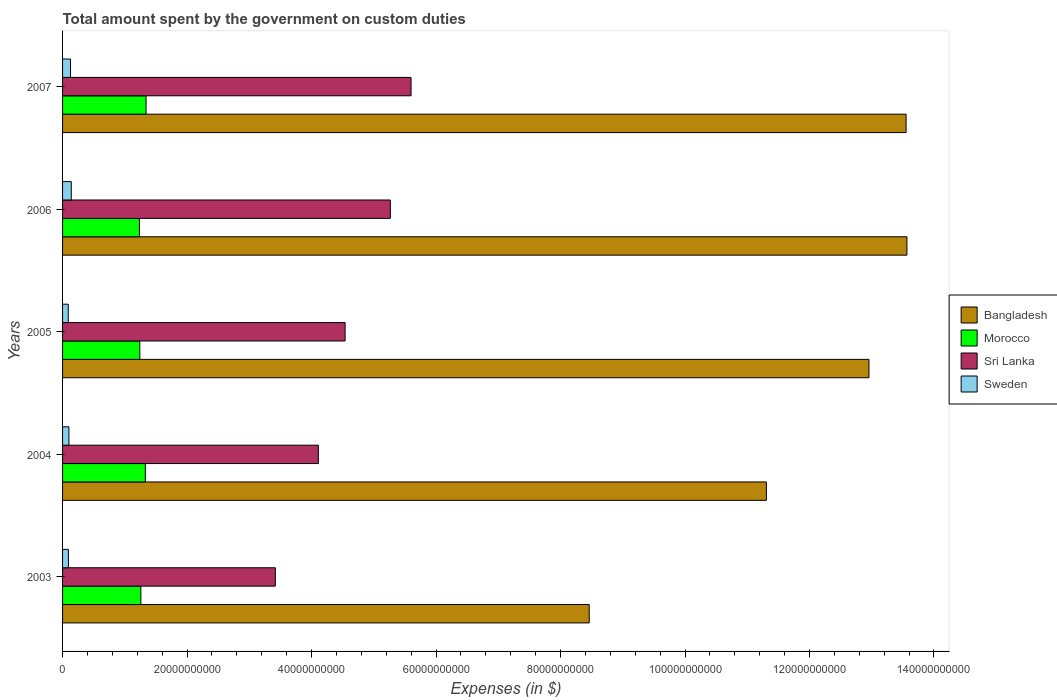How many different coloured bars are there?
Offer a very short reply. 4. How many bars are there on the 1st tick from the top?
Your response must be concise. 4. In how many cases, is the number of bars for a given year not equal to the number of legend labels?
Offer a very short reply. 0. What is the amount spent on custom duties by the government in Sri Lanka in 2006?
Ensure brevity in your answer.  5.27e+1. Across all years, what is the maximum amount spent on custom duties by the government in Morocco?
Provide a short and direct response. 1.34e+1. Across all years, what is the minimum amount spent on custom duties by the government in Sri Lanka?
Make the answer very short. 3.42e+1. What is the total amount spent on custom duties by the government in Sri Lanka in the graph?
Make the answer very short. 2.29e+11. What is the difference between the amount spent on custom duties by the government in Sri Lanka in 2006 and that in 2007?
Give a very brief answer. -3.33e+09. What is the difference between the amount spent on custom duties by the government in Sweden in 2004 and the amount spent on custom duties by the government in Sri Lanka in 2003?
Give a very brief answer. -3.32e+1. What is the average amount spent on custom duties by the government in Sri Lanka per year?
Offer a terse response. 4.59e+1. In the year 2004, what is the difference between the amount spent on custom duties by the government in Morocco and amount spent on custom duties by the government in Bangladesh?
Provide a succinct answer. -9.98e+1. What is the ratio of the amount spent on custom duties by the government in Sweden in 2003 to that in 2005?
Keep it short and to the point. 1.03. Is the difference between the amount spent on custom duties by the government in Morocco in 2003 and 2006 greater than the difference between the amount spent on custom duties by the government in Bangladesh in 2003 and 2006?
Make the answer very short. Yes. What is the difference between the highest and the second highest amount spent on custom duties by the government in Morocco?
Provide a short and direct response. 1.22e+08. What is the difference between the highest and the lowest amount spent on custom duties by the government in Morocco?
Your answer should be compact. 1.07e+09. Is it the case that in every year, the sum of the amount spent on custom duties by the government in Sweden and amount spent on custom duties by the government in Morocco is greater than the sum of amount spent on custom duties by the government in Bangladesh and amount spent on custom duties by the government in Sri Lanka?
Provide a succinct answer. No. What does the 2nd bar from the top in 2007 represents?
Offer a terse response. Sri Lanka. What does the 3rd bar from the bottom in 2004 represents?
Ensure brevity in your answer.  Sri Lanka. Is it the case that in every year, the sum of the amount spent on custom duties by the government in Sweden and amount spent on custom duties by the government in Sri Lanka is greater than the amount spent on custom duties by the government in Morocco?
Your answer should be compact. Yes. Are the values on the major ticks of X-axis written in scientific E-notation?
Give a very brief answer. No. Does the graph contain grids?
Keep it short and to the point. No. Where does the legend appear in the graph?
Make the answer very short. Center right. How many legend labels are there?
Provide a short and direct response. 4. How are the legend labels stacked?
Keep it short and to the point. Vertical. What is the title of the graph?
Your response must be concise. Total amount spent by the government on custom duties. Does "Maldives" appear as one of the legend labels in the graph?
Give a very brief answer. No. What is the label or title of the X-axis?
Offer a very short reply. Expenses (in $). What is the Expenses (in $) of Bangladesh in 2003?
Your answer should be very brief. 8.46e+1. What is the Expenses (in $) in Morocco in 2003?
Your answer should be compact. 1.26e+1. What is the Expenses (in $) in Sri Lanka in 2003?
Provide a succinct answer. 3.42e+1. What is the Expenses (in $) of Sweden in 2003?
Provide a succinct answer. 9.39e+08. What is the Expenses (in $) of Bangladesh in 2004?
Your answer should be very brief. 1.13e+11. What is the Expenses (in $) in Morocco in 2004?
Make the answer very short. 1.33e+1. What is the Expenses (in $) in Sri Lanka in 2004?
Offer a terse response. 4.11e+1. What is the Expenses (in $) of Sweden in 2004?
Keep it short and to the point. 1.02e+09. What is the Expenses (in $) of Bangladesh in 2005?
Provide a succinct answer. 1.30e+11. What is the Expenses (in $) in Morocco in 2005?
Give a very brief answer. 1.24e+1. What is the Expenses (in $) in Sri Lanka in 2005?
Give a very brief answer. 4.54e+1. What is the Expenses (in $) in Sweden in 2005?
Provide a succinct answer. 9.12e+08. What is the Expenses (in $) of Bangladesh in 2006?
Provide a succinct answer. 1.36e+11. What is the Expenses (in $) in Morocco in 2006?
Offer a very short reply. 1.23e+1. What is the Expenses (in $) of Sri Lanka in 2006?
Provide a succinct answer. 5.27e+1. What is the Expenses (in $) in Sweden in 2006?
Make the answer very short. 1.40e+09. What is the Expenses (in $) in Bangladesh in 2007?
Your response must be concise. 1.36e+11. What is the Expenses (in $) of Morocco in 2007?
Ensure brevity in your answer.  1.34e+1. What is the Expenses (in $) of Sri Lanka in 2007?
Make the answer very short. 5.60e+1. What is the Expenses (in $) of Sweden in 2007?
Your answer should be compact. 1.28e+09. Across all years, what is the maximum Expenses (in $) in Bangladesh?
Offer a very short reply. 1.36e+11. Across all years, what is the maximum Expenses (in $) of Morocco?
Your answer should be compact. 1.34e+1. Across all years, what is the maximum Expenses (in $) of Sri Lanka?
Keep it short and to the point. 5.60e+1. Across all years, what is the maximum Expenses (in $) of Sweden?
Offer a very short reply. 1.40e+09. Across all years, what is the minimum Expenses (in $) of Bangladesh?
Keep it short and to the point. 8.46e+1. Across all years, what is the minimum Expenses (in $) in Morocco?
Your answer should be compact. 1.23e+1. Across all years, what is the minimum Expenses (in $) in Sri Lanka?
Make the answer very short. 3.42e+1. Across all years, what is the minimum Expenses (in $) of Sweden?
Your answer should be very brief. 9.12e+08. What is the total Expenses (in $) in Bangladesh in the graph?
Make the answer very short. 5.98e+11. What is the total Expenses (in $) of Morocco in the graph?
Offer a terse response. 6.40e+1. What is the total Expenses (in $) of Sri Lanka in the graph?
Provide a short and direct response. 2.29e+11. What is the total Expenses (in $) of Sweden in the graph?
Provide a short and direct response. 5.55e+09. What is the difference between the Expenses (in $) in Bangladesh in 2003 and that in 2004?
Make the answer very short. -2.85e+1. What is the difference between the Expenses (in $) of Morocco in 2003 and that in 2004?
Make the answer very short. -7.15e+08. What is the difference between the Expenses (in $) in Sri Lanka in 2003 and that in 2004?
Provide a succinct answer. -6.91e+09. What is the difference between the Expenses (in $) of Sweden in 2003 and that in 2004?
Give a very brief answer. -8.30e+07. What is the difference between the Expenses (in $) of Bangladesh in 2003 and that in 2005?
Your answer should be compact. -4.49e+1. What is the difference between the Expenses (in $) in Morocco in 2003 and that in 2005?
Ensure brevity in your answer.  1.69e+08. What is the difference between the Expenses (in $) in Sri Lanka in 2003 and that in 2005?
Make the answer very short. -1.12e+1. What is the difference between the Expenses (in $) of Sweden in 2003 and that in 2005?
Ensure brevity in your answer.  2.70e+07. What is the difference between the Expenses (in $) in Bangladesh in 2003 and that in 2006?
Offer a terse response. -5.10e+1. What is the difference between the Expenses (in $) in Morocco in 2003 and that in 2006?
Keep it short and to the point. 2.34e+08. What is the difference between the Expenses (in $) of Sri Lanka in 2003 and that in 2006?
Make the answer very short. -1.85e+1. What is the difference between the Expenses (in $) in Sweden in 2003 and that in 2006?
Offer a terse response. -4.61e+08. What is the difference between the Expenses (in $) of Bangladesh in 2003 and that in 2007?
Give a very brief answer. -5.09e+1. What is the difference between the Expenses (in $) of Morocco in 2003 and that in 2007?
Ensure brevity in your answer.  -8.37e+08. What is the difference between the Expenses (in $) in Sri Lanka in 2003 and that in 2007?
Give a very brief answer. -2.18e+1. What is the difference between the Expenses (in $) in Sweden in 2003 and that in 2007?
Provide a short and direct response. -3.41e+08. What is the difference between the Expenses (in $) of Bangladesh in 2004 and that in 2005?
Provide a short and direct response. -1.65e+1. What is the difference between the Expenses (in $) in Morocco in 2004 and that in 2005?
Give a very brief answer. 8.84e+08. What is the difference between the Expenses (in $) in Sri Lanka in 2004 and that in 2005?
Make the answer very short. -4.29e+09. What is the difference between the Expenses (in $) of Sweden in 2004 and that in 2005?
Provide a short and direct response. 1.10e+08. What is the difference between the Expenses (in $) in Bangladesh in 2004 and that in 2006?
Offer a terse response. -2.26e+1. What is the difference between the Expenses (in $) of Morocco in 2004 and that in 2006?
Provide a succinct answer. 9.49e+08. What is the difference between the Expenses (in $) in Sri Lanka in 2004 and that in 2006?
Ensure brevity in your answer.  -1.16e+1. What is the difference between the Expenses (in $) in Sweden in 2004 and that in 2006?
Make the answer very short. -3.78e+08. What is the difference between the Expenses (in $) of Bangladesh in 2004 and that in 2007?
Give a very brief answer. -2.24e+1. What is the difference between the Expenses (in $) in Morocco in 2004 and that in 2007?
Offer a terse response. -1.22e+08. What is the difference between the Expenses (in $) of Sri Lanka in 2004 and that in 2007?
Your answer should be compact. -1.49e+1. What is the difference between the Expenses (in $) of Sweden in 2004 and that in 2007?
Make the answer very short. -2.58e+08. What is the difference between the Expenses (in $) in Bangladesh in 2005 and that in 2006?
Provide a short and direct response. -6.10e+09. What is the difference between the Expenses (in $) in Morocco in 2005 and that in 2006?
Provide a short and direct response. 6.50e+07. What is the difference between the Expenses (in $) of Sri Lanka in 2005 and that in 2006?
Give a very brief answer. -7.27e+09. What is the difference between the Expenses (in $) of Sweden in 2005 and that in 2006?
Offer a terse response. -4.88e+08. What is the difference between the Expenses (in $) in Bangladesh in 2005 and that in 2007?
Provide a short and direct response. -5.96e+09. What is the difference between the Expenses (in $) of Morocco in 2005 and that in 2007?
Your answer should be compact. -1.01e+09. What is the difference between the Expenses (in $) of Sri Lanka in 2005 and that in 2007?
Give a very brief answer. -1.06e+1. What is the difference between the Expenses (in $) of Sweden in 2005 and that in 2007?
Offer a terse response. -3.68e+08. What is the difference between the Expenses (in $) of Bangladesh in 2006 and that in 2007?
Offer a very short reply. 1.33e+08. What is the difference between the Expenses (in $) of Morocco in 2006 and that in 2007?
Keep it short and to the point. -1.07e+09. What is the difference between the Expenses (in $) in Sri Lanka in 2006 and that in 2007?
Offer a very short reply. -3.33e+09. What is the difference between the Expenses (in $) of Sweden in 2006 and that in 2007?
Make the answer very short. 1.20e+08. What is the difference between the Expenses (in $) of Bangladesh in 2003 and the Expenses (in $) of Morocco in 2004?
Make the answer very short. 7.13e+1. What is the difference between the Expenses (in $) in Bangladesh in 2003 and the Expenses (in $) in Sri Lanka in 2004?
Offer a very short reply. 4.35e+1. What is the difference between the Expenses (in $) in Bangladesh in 2003 and the Expenses (in $) in Sweden in 2004?
Ensure brevity in your answer.  8.36e+1. What is the difference between the Expenses (in $) of Morocco in 2003 and the Expenses (in $) of Sri Lanka in 2004?
Offer a terse response. -2.85e+1. What is the difference between the Expenses (in $) of Morocco in 2003 and the Expenses (in $) of Sweden in 2004?
Keep it short and to the point. 1.16e+1. What is the difference between the Expenses (in $) in Sri Lanka in 2003 and the Expenses (in $) in Sweden in 2004?
Make the answer very short. 3.32e+1. What is the difference between the Expenses (in $) in Bangladesh in 2003 and the Expenses (in $) in Morocco in 2005?
Your response must be concise. 7.22e+1. What is the difference between the Expenses (in $) of Bangladesh in 2003 and the Expenses (in $) of Sri Lanka in 2005?
Offer a very short reply. 3.92e+1. What is the difference between the Expenses (in $) of Bangladesh in 2003 and the Expenses (in $) of Sweden in 2005?
Keep it short and to the point. 8.37e+1. What is the difference between the Expenses (in $) of Morocco in 2003 and the Expenses (in $) of Sri Lanka in 2005?
Your response must be concise. -3.28e+1. What is the difference between the Expenses (in $) in Morocco in 2003 and the Expenses (in $) in Sweden in 2005?
Make the answer very short. 1.17e+1. What is the difference between the Expenses (in $) in Sri Lanka in 2003 and the Expenses (in $) in Sweden in 2005?
Make the answer very short. 3.33e+1. What is the difference between the Expenses (in $) of Bangladesh in 2003 and the Expenses (in $) of Morocco in 2006?
Offer a very short reply. 7.23e+1. What is the difference between the Expenses (in $) in Bangladesh in 2003 and the Expenses (in $) in Sri Lanka in 2006?
Provide a succinct answer. 3.19e+1. What is the difference between the Expenses (in $) in Bangladesh in 2003 and the Expenses (in $) in Sweden in 2006?
Make the answer very short. 8.32e+1. What is the difference between the Expenses (in $) in Morocco in 2003 and the Expenses (in $) in Sri Lanka in 2006?
Your answer should be compact. -4.01e+1. What is the difference between the Expenses (in $) in Morocco in 2003 and the Expenses (in $) in Sweden in 2006?
Your answer should be compact. 1.12e+1. What is the difference between the Expenses (in $) in Sri Lanka in 2003 and the Expenses (in $) in Sweden in 2006?
Your answer should be very brief. 3.28e+1. What is the difference between the Expenses (in $) of Bangladesh in 2003 and the Expenses (in $) of Morocco in 2007?
Make the answer very short. 7.12e+1. What is the difference between the Expenses (in $) of Bangladesh in 2003 and the Expenses (in $) of Sri Lanka in 2007?
Your answer should be compact. 2.86e+1. What is the difference between the Expenses (in $) in Bangladesh in 2003 and the Expenses (in $) in Sweden in 2007?
Offer a very short reply. 8.33e+1. What is the difference between the Expenses (in $) in Morocco in 2003 and the Expenses (in $) in Sri Lanka in 2007?
Provide a succinct answer. -4.34e+1. What is the difference between the Expenses (in $) in Morocco in 2003 and the Expenses (in $) in Sweden in 2007?
Offer a terse response. 1.13e+1. What is the difference between the Expenses (in $) of Sri Lanka in 2003 and the Expenses (in $) of Sweden in 2007?
Your answer should be very brief. 3.29e+1. What is the difference between the Expenses (in $) in Bangladesh in 2004 and the Expenses (in $) in Morocco in 2005?
Keep it short and to the point. 1.01e+11. What is the difference between the Expenses (in $) of Bangladesh in 2004 and the Expenses (in $) of Sri Lanka in 2005?
Give a very brief answer. 6.77e+1. What is the difference between the Expenses (in $) in Bangladesh in 2004 and the Expenses (in $) in Sweden in 2005?
Offer a very short reply. 1.12e+11. What is the difference between the Expenses (in $) in Morocco in 2004 and the Expenses (in $) in Sri Lanka in 2005?
Your answer should be very brief. -3.21e+1. What is the difference between the Expenses (in $) in Morocco in 2004 and the Expenses (in $) in Sweden in 2005?
Your answer should be compact. 1.24e+1. What is the difference between the Expenses (in $) of Sri Lanka in 2004 and the Expenses (in $) of Sweden in 2005?
Ensure brevity in your answer.  4.02e+1. What is the difference between the Expenses (in $) of Bangladesh in 2004 and the Expenses (in $) of Morocco in 2006?
Your answer should be compact. 1.01e+11. What is the difference between the Expenses (in $) in Bangladesh in 2004 and the Expenses (in $) in Sri Lanka in 2006?
Make the answer very short. 6.04e+1. What is the difference between the Expenses (in $) in Bangladesh in 2004 and the Expenses (in $) in Sweden in 2006?
Give a very brief answer. 1.12e+11. What is the difference between the Expenses (in $) in Morocco in 2004 and the Expenses (in $) in Sri Lanka in 2006?
Keep it short and to the point. -3.94e+1. What is the difference between the Expenses (in $) in Morocco in 2004 and the Expenses (in $) in Sweden in 2006?
Make the answer very short. 1.19e+1. What is the difference between the Expenses (in $) in Sri Lanka in 2004 and the Expenses (in $) in Sweden in 2006?
Your answer should be very brief. 3.97e+1. What is the difference between the Expenses (in $) of Bangladesh in 2004 and the Expenses (in $) of Morocco in 2007?
Your answer should be very brief. 9.97e+1. What is the difference between the Expenses (in $) of Bangladesh in 2004 and the Expenses (in $) of Sri Lanka in 2007?
Your answer should be compact. 5.71e+1. What is the difference between the Expenses (in $) in Bangladesh in 2004 and the Expenses (in $) in Sweden in 2007?
Make the answer very short. 1.12e+11. What is the difference between the Expenses (in $) in Morocco in 2004 and the Expenses (in $) in Sri Lanka in 2007?
Keep it short and to the point. -4.27e+1. What is the difference between the Expenses (in $) in Morocco in 2004 and the Expenses (in $) in Sweden in 2007?
Your response must be concise. 1.20e+1. What is the difference between the Expenses (in $) in Sri Lanka in 2004 and the Expenses (in $) in Sweden in 2007?
Provide a succinct answer. 3.98e+1. What is the difference between the Expenses (in $) in Bangladesh in 2005 and the Expenses (in $) in Morocco in 2006?
Make the answer very short. 1.17e+11. What is the difference between the Expenses (in $) of Bangladesh in 2005 and the Expenses (in $) of Sri Lanka in 2006?
Make the answer very short. 7.69e+1. What is the difference between the Expenses (in $) in Bangladesh in 2005 and the Expenses (in $) in Sweden in 2006?
Provide a short and direct response. 1.28e+11. What is the difference between the Expenses (in $) in Morocco in 2005 and the Expenses (in $) in Sri Lanka in 2006?
Offer a very short reply. -4.03e+1. What is the difference between the Expenses (in $) in Morocco in 2005 and the Expenses (in $) in Sweden in 2006?
Make the answer very short. 1.10e+1. What is the difference between the Expenses (in $) of Sri Lanka in 2005 and the Expenses (in $) of Sweden in 2006?
Provide a succinct answer. 4.40e+1. What is the difference between the Expenses (in $) of Bangladesh in 2005 and the Expenses (in $) of Morocco in 2007?
Ensure brevity in your answer.  1.16e+11. What is the difference between the Expenses (in $) of Bangladesh in 2005 and the Expenses (in $) of Sri Lanka in 2007?
Keep it short and to the point. 7.36e+1. What is the difference between the Expenses (in $) in Bangladesh in 2005 and the Expenses (in $) in Sweden in 2007?
Provide a short and direct response. 1.28e+11. What is the difference between the Expenses (in $) of Morocco in 2005 and the Expenses (in $) of Sri Lanka in 2007?
Your answer should be very brief. -4.36e+1. What is the difference between the Expenses (in $) in Morocco in 2005 and the Expenses (in $) in Sweden in 2007?
Ensure brevity in your answer.  1.11e+1. What is the difference between the Expenses (in $) of Sri Lanka in 2005 and the Expenses (in $) of Sweden in 2007?
Ensure brevity in your answer.  4.41e+1. What is the difference between the Expenses (in $) in Bangladesh in 2006 and the Expenses (in $) in Morocco in 2007?
Provide a short and direct response. 1.22e+11. What is the difference between the Expenses (in $) of Bangladesh in 2006 and the Expenses (in $) of Sri Lanka in 2007?
Ensure brevity in your answer.  7.97e+1. What is the difference between the Expenses (in $) in Bangladesh in 2006 and the Expenses (in $) in Sweden in 2007?
Keep it short and to the point. 1.34e+11. What is the difference between the Expenses (in $) of Morocco in 2006 and the Expenses (in $) of Sri Lanka in 2007?
Provide a short and direct response. -4.36e+1. What is the difference between the Expenses (in $) in Morocco in 2006 and the Expenses (in $) in Sweden in 2007?
Keep it short and to the point. 1.11e+1. What is the difference between the Expenses (in $) in Sri Lanka in 2006 and the Expenses (in $) in Sweden in 2007?
Ensure brevity in your answer.  5.14e+1. What is the average Expenses (in $) of Bangladesh per year?
Offer a terse response. 1.20e+11. What is the average Expenses (in $) of Morocco per year?
Provide a short and direct response. 1.28e+1. What is the average Expenses (in $) of Sri Lanka per year?
Your answer should be compact. 4.59e+1. What is the average Expenses (in $) of Sweden per year?
Provide a succinct answer. 1.11e+09. In the year 2003, what is the difference between the Expenses (in $) of Bangladesh and Expenses (in $) of Morocco?
Ensure brevity in your answer.  7.20e+1. In the year 2003, what is the difference between the Expenses (in $) of Bangladesh and Expenses (in $) of Sri Lanka?
Keep it short and to the point. 5.04e+1. In the year 2003, what is the difference between the Expenses (in $) in Bangladesh and Expenses (in $) in Sweden?
Give a very brief answer. 8.37e+1. In the year 2003, what is the difference between the Expenses (in $) in Morocco and Expenses (in $) in Sri Lanka?
Keep it short and to the point. -2.16e+1. In the year 2003, what is the difference between the Expenses (in $) of Morocco and Expenses (in $) of Sweden?
Keep it short and to the point. 1.16e+1. In the year 2003, what is the difference between the Expenses (in $) of Sri Lanka and Expenses (in $) of Sweden?
Offer a very short reply. 3.32e+1. In the year 2004, what is the difference between the Expenses (in $) of Bangladesh and Expenses (in $) of Morocco?
Make the answer very short. 9.98e+1. In the year 2004, what is the difference between the Expenses (in $) of Bangladesh and Expenses (in $) of Sri Lanka?
Your response must be concise. 7.20e+1. In the year 2004, what is the difference between the Expenses (in $) of Bangladesh and Expenses (in $) of Sweden?
Make the answer very short. 1.12e+11. In the year 2004, what is the difference between the Expenses (in $) in Morocco and Expenses (in $) in Sri Lanka?
Give a very brief answer. -2.78e+1. In the year 2004, what is the difference between the Expenses (in $) in Morocco and Expenses (in $) in Sweden?
Give a very brief answer. 1.23e+1. In the year 2004, what is the difference between the Expenses (in $) in Sri Lanka and Expenses (in $) in Sweden?
Provide a succinct answer. 4.01e+1. In the year 2005, what is the difference between the Expenses (in $) in Bangladesh and Expenses (in $) in Morocco?
Offer a very short reply. 1.17e+11. In the year 2005, what is the difference between the Expenses (in $) in Bangladesh and Expenses (in $) in Sri Lanka?
Provide a short and direct response. 8.42e+1. In the year 2005, what is the difference between the Expenses (in $) in Bangladesh and Expenses (in $) in Sweden?
Make the answer very short. 1.29e+11. In the year 2005, what is the difference between the Expenses (in $) of Morocco and Expenses (in $) of Sri Lanka?
Your response must be concise. -3.30e+1. In the year 2005, what is the difference between the Expenses (in $) in Morocco and Expenses (in $) in Sweden?
Provide a short and direct response. 1.15e+1. In the year 2005, what is the difference between the Expenses (in $) of Sri Lanka and Expenses (in $) of Sweden?
Ensure brevity in your answer.  4.45e+1. In the year 2006, what is the difference between the Expenses (in $) of Bangladesh and Expenses (in $) of Morocco?
Offer a very short reply. 1.23e+11. In the year 2006, what is the difference between the Expenses (in $) in Bangladesh and Expenses (in $) in Sri Lanka?
Provide a succinct answer. 8.30e+1. In the year 2006, what is the difference between the Expenses (in $) of Bangladesh and Expenses (in $) of Sweden?
Your answer should be compact. 1.34e+11. In the year 2006, what is the difference between the Expenses (in $) in Morocco and Expenses (in $) in Sri Lanka?
Ensure brevity in your answer.  -4.03e+1. In the year 2006, what is the difference between the Expenses (in $) of Morocco and Expenses (in $) of Sweden?
Offer a very short reply. 1.09e+1. In the year 2006, what is the difference between the Expenses (in $) of Sri Lanka and Expenses (in $) of Sweden?
Ensure brevity in your answer.  5.13e+1. In the year 2007, what is the difference between the Expenses (in $) of Bangladesh and Expenses (in $) of Morocco?
Your response must be concise. 1.22e+11. In the year 2007, what is the difference between the Expenses (in $) in Bangladesh and Expenses (in $) in Sri Lanka?
Keep it short and to the point. 7.95e+1. In the year 2007, what is the difference between the Expenses (in $) in Bangladesh and Expenses (in $) in Sweden?
Make the answer very short. 1.34e+11. In the year 2007, what is the difference between the Expenses (in $) of Morocco and Expenses (in $) of Sri Lanka?
Provide a succinct answer. -4.26e+1. In the year 2007, what is the difference between the Expenses (in $) in Morocco and Expenses (in $) in Sweden?
Make the answer very short. 1.21e+1. In the year 2007, what is the difference between the Expenses (in $) of Sri Lanka and Expenses (in $) of Sweden?
Provide a short and direct response. 5.47e+1. What is the ratio of the Expenses (in $) in Bangladesh in 2003 to that in 2004?
Your answer should be compact. 0.75. What is the ratio of the Expenses (in $) of Morocco in 2003 to that in 2004?
Provide a succinct answer. 0.95. What is the ratio of the Expenses (in $) in Sri Lanka in 2003 to that in 2004?
Provide a short and direct response. 0.83. What is the ratio of the Expenses (in $) in Sweden in 2003 to that in 2004?
Offer a terse response. 0.92. What is the ratio of the Expenses (in $) in Bangladesh in 2003 to that in 2005?
Provide a short and direct response. 0.65. What is the ratio of the Expenses (in $) of Morocco in 2003 to that in 2005?
Offer a terse response. 1.01. What is the ratio of the Expenses (in $) in Sri Lanka in 2003 to that in 2005?
Keep it short and to the point. 0.75. What is the ratio of the Expenses (in $) in Sweden in 2003 to that in 2005?
Make the answer very short. 1.03. What is the ratio of the Expenses (in $) of Bangladesh in 2003 to that in 2006?
Provide a succinct answer. 0.62. What is the ratio of the Expenses (in $) of Morocco in 2003 to that in 2006?
Provide a succinct answer. 1.02. What is the ratio of the Expenses (in $) in Sri Lanka in 2003 to that in 2006?
Provide a succinct answer. 0.65. What is the ratio of the Expenses (in $) in Sweden in 2003 to that in 2006?
Offer a terse response. 0.67. What is the ratio of the Expenses (in $) in Bangladesh in 2003 to that in 2007?
Provide a short and direct response. 0.62. What is the ratio of the Expenses (in $) of Morocco in 2003 to that in 2007?
Offer a very short reply. 0.94. What is the ratio of the Expenses (in $) of Sri Lanka in 2003 to that in 2007?
Offer a very short reply. 0.61. What is the ratio of the Expenses (in $) in Sweden in 2003 to that in 2007?
Your response must be concise. 0.73. What is the ratio of the Expenses (in $) of Bangladesh in 2004 to that in 2005?
Offer a very short reply. 0.87. What is the ratio of the Expenses (in $) of Morocco in 2004 to that in 2005?
Keep it short and to the point. 1.07. What is the ratio of the Expenses (in $) in Sri Lanka in 2004 to that in 2005?
Provide a short and direct response. 0.91. What is the ratio of the Expenses (in $) of Sweden in 2004 to that in 2005?
Your answer should be compact. 1.12. What is the ratio of the Expenses (in $) in Bangladesh in 2004 to that in 2006?
Keep it short and to the point. 0.83. What is the ratio of the Expenses (in $) in Morocco in 2004 to that in 2006?
Provide a short and direct response. 1.08. What is the ratio of the Expenses (in $) of Sri Lanka in 2004 to that in 2006?
Offer a terse response. 0.78. What is the ratio of the Expenses (in $) in Sweden in 2004 to that in 2006?
Your answer should be very brief. 0.73. What is the ratio of the Expenses (in $) of Bangladesh in 2004 to that in 2007?
Your response must be concise. 0.83. What is the ratio of the Expenses (in $) of Morocco in 2004 to that in 2007?
Keep it short and to the point. 0.99. What is the ratio of the Expenses (in $) of Sri Lanka in 2004 to that in 2007?
Offer a very short reply. 0.73. What is the ratio of the Expenses (in $) in Sweden in 2004 to that in 2007?
Your answer should be very brief. 0.8. What is the ratio of the Expenses (in $) of Bangladesh in 2005 to that in 2006?
Your answer should be very brief. 0.95. What is the ratio of the Expenses (in $) of Morocco in 2005 to that in 2006?
Make the answer very short. 1.01. What is the ratio of the Expenses (in $) in Sri Lanka in 2005 to that in 2006?
Provide a short and direct response. 0.86. What is the ratio of the Expenses (in $) of Sweden in 2005 to that in 2006?
Your answer should be compact. 0.65. What is the ratio of the Expenses (in $) in Bangladesh in 2005 to that in 2007?
Ensure brevity in your answer.  0.96. What is the ratio of the Expenses (in $) of Morocco in 2005 to that in 2007?
Keep it short and to the point. 0.93. What is the ratio of the Expenses (in $) of Sri Lanka in 2005 to that in 2007?
Your answer should be very brief. 0.81. What is the ratio of the Expenses (in $) in Sweden in 2005 to that in 2007?
Your answer should be very brief. 0.71. What is the ratio of the Expenses (in $) in Bangladesh in 2006 to that in 2007?
Make the answer very short. 1. What is the ratio of the Expenses (in $) of Morocco in 2006 to that in 2007?
Offer a very short reply. 0.92. What is the ratio of the Expenses (in $) in Sri Lanka in 2006 to that in 2007?
Your response must be concise. 0.94. What is the ratio of the Expenses (in $) of Sweden in 2006 to that in 2007?
Your answer should be very brief. 1.09. What is the difference between the highest and the second highest Expenses (in $) of Bangladesh?
Provide a short and direct response. 1.33e+08. What is the difference between the highest and the second highest Expenses (in $) in Morocco?
Offer a very short reply. 1.22e+08. What is the difference between the highest and the second highest Expenses (in $) in Sri Lanka?
Your answer should be compact. 3.33e+09. What is the difference between the highest and the second highest Expenses (in $) in Sweden?
Give a very brief answer. 1.20e+08. What is the difference between the highest and the lowest Expenses (in $) of Bangladesh?
Your answer should be compact. 5.10e+1. What is the difference between the highest and the lowest Expenses (in $) of Morocco?
Offer a terse response. 1.07e+09. What is the difference between the highest and the lowest Expenses (in $) in Sri Lanka?
Your answer should be compact. 2.18e+1. What is the difference between the highest and the lowest Expenses (in $) of Sweden?
Ensure brevity in your answer.  4.88e+08. 